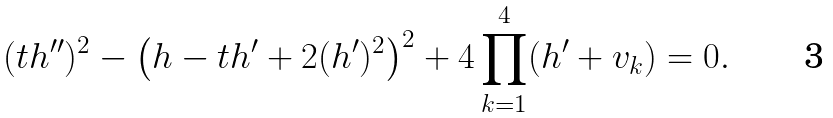Convert formula to latex. <formula><loc_0><loc_0><loc_500><loc_500>( t h ^ { \prime \prime } ) ^ { 2 } - \left ( h - t h ^ { \prime } + 2 ( h ^ { \prime } ) ^ { 2 } \right ) ^ { 2 } + 4 \prod _ { k = 1 } ^ { 4 } ( h ^ { \prime } + v _ { k } ) = 0 .</formula> 